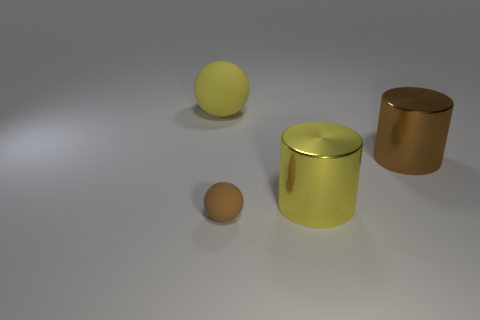Add 1 large brown spheres. How many objects exist? 5 Subtract 1 cylinders. How many cylinders are left? 1 Subtract all small spheres. Subtract all tiny matte spheres. How many objects are left? 2 Add 1 big matte spheres. How many big matte spheres are left? 2 Add 3 big matte things. How many big matte things exist? 4 Subtract 0 cyan spheres. How many objects are left? 4 Subtract all blue cylinders. Subtract all green blocks. How many cylinders are left? 2 